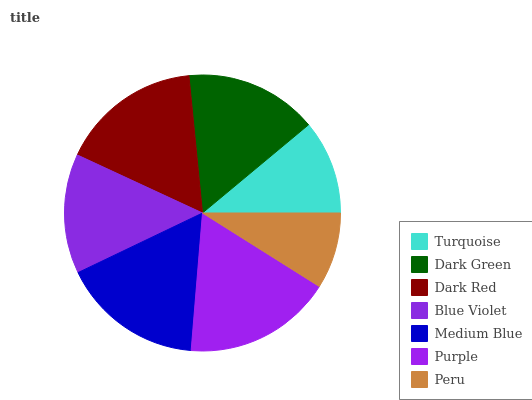Is Peru the minimum?
Answer yes or no. Yes. Is Purple the maximum?
Answer yes or no. Yes. Is Dark Green the minimum?
Answer yes or no. No. Is Dark Green the maximum?
Answer yes or no. No. Is Dark Green greater than Turquoise?
Answer yes or no. Yes. Is Turquoise less than Dark Green?
Answer yes or no. Yes. Is Turquoise greater than Dark Green?
Answer yes or no. No. Is Dark Green less than Turquoise?
Answer yes or no. No. Is Dark Green the high median?
Answer yes or no. Yes. Is Dark Green the low median?
Answer yes or no. Yes. Is Medium Blue the high median?
Answer yes or no. No. Is Purple the low median?
Answer yes or no. No. 